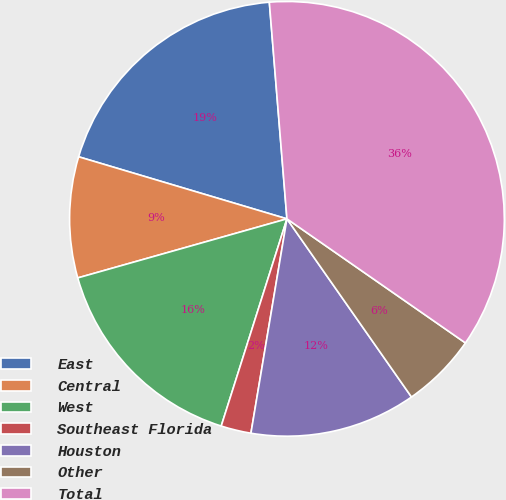Convert chart. <chart><loc_0><loc_0><loc_500><loc_500><pie_chart><fcel>East<fcel>Central<fcel>West<fcel>Southeast Florida<fcel>Houston<fcel>Other<fcel>Total<nl><fcel>19.1%<fcel>8.99%<fcel>15.73%<fcel>2.24%<fcel>12.36%<fcel>5.62%<fcel>35.96%<nl></chart> 